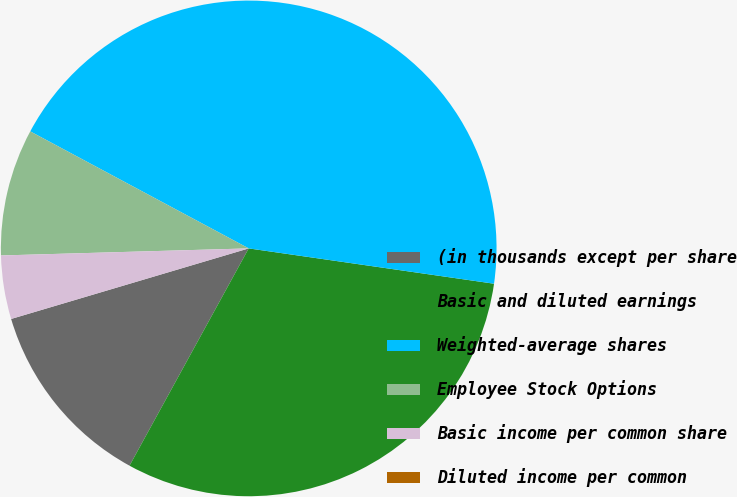Convert chart to OTSL. <chart><loc_0><loc_0><loc_500><loc_500><pie_chart><fcel>(in thousands except per share<fcel>Basic and diluted earnings<fcel>Weighted-average shares<fcel>Employee Stock Options<fcel>Basic income per common share<fcel>Diluted income per common<nl><fcel>12.42%<fcel>30.71%<fcel>44.45%<fcel>8.28%<fcel>4.14%<fcel>0.0%<nl></chart> 